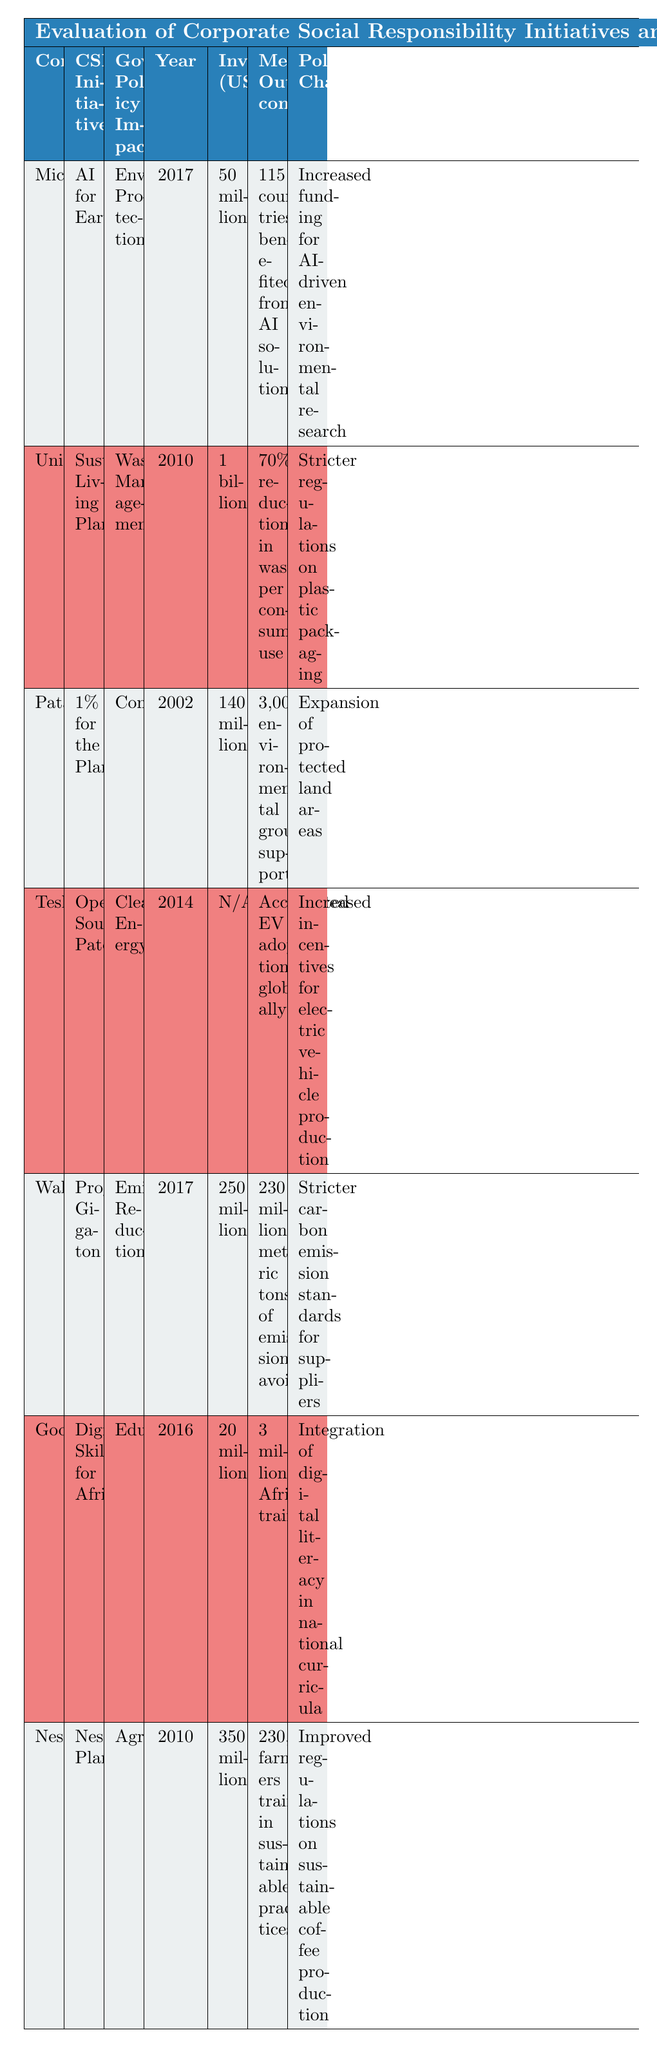What is the total investment made by Microsoft and Unilever combined? To find the total investment, we need to add the investments from both companies: Microsoft invested 50 million and Unilever invested 1 billion. We convert 1 billion to million for easy addition: 1 billion equals 1000 million. Thus, 50 million + 1000 million = 1050 million.
Answer: 1050 million Which company's CSR initiative focused on education and what was the measurable outcome? Looking at the table, the initiative that focused on education is "Digital Skills for Africa" by Google. The measurable outcome for this initiative is that 3 million Africans were trained.
Answer: Google; 3 million Africans trained Did Patagonia implement its CSR initiative before 2010? The year implemented for Patagonia's "1% for the Planet" initiative is 2002. Since 2002 is before 2010, the statement is true.
Answer: Yes What was the impact of Walmart's CSR initiative on supplier standards? Walmart's CSR initiative "Project Gigaton" resulted in stricter carbon emission standards for suppliers. This information can be directly read from the "Policy Change" column corresponding to Walmart in the table.
Answer: Stricter carbon emission standards for suppliers How many environmental groups were supported by Patagonia's initiative compared to the total measurable outcomes of Microsoft’s initiative? Patagonia's "1% for the Planet" initiative supported over 3,000 environmental groups. Microsoft’s "AI for Earth" initiative had a measurable outcome of benefiting 115 countries. Since these outcomes are not directly comparable, we can say they are significantly different types of metrics. Thus, one is focused on groups supported, while the other is about countries benefited.
Answer: Not directly comparable What was the year of implementation for the CSR initiative that focused on clean energy? The CSR initiative focused on clean energy is "Open-Source Patents" by Tesla, which was implemented in the year 2014. This information is found in the respective row under the "Year Implemented" column for Tesla.
Answer: 2014 Which company made the highest investment in its CSR initiative? From the investment information, Unilever made the highest investment of 1 billion. To confirm, we can quickly scan through the "Investment (USD)" column and identify that no other company listed exceeds this amount.
Answer: Unilever Is it true that all CSR initiatives listed resulted in policy changes? By reviewing the "Policy Change" column for each company's initiative, all companies listed do have a corresponding policy change. Therefore, the answer is true.
Answer: Yes 